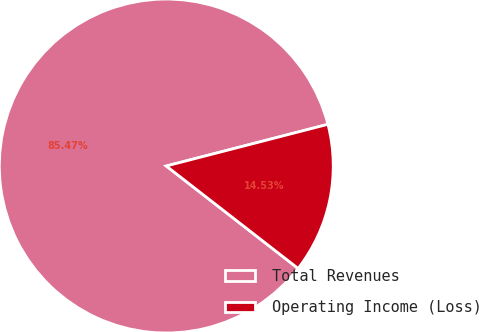Convert chart to OTSL. <chart><loc_0><loc_0><loc_500><loc_500><pie_chart><fcel>Total Revenues<fcel>Operating Income (Loss)<nl><fcel>85.47%<fcel>14.53%<nl></chart> 